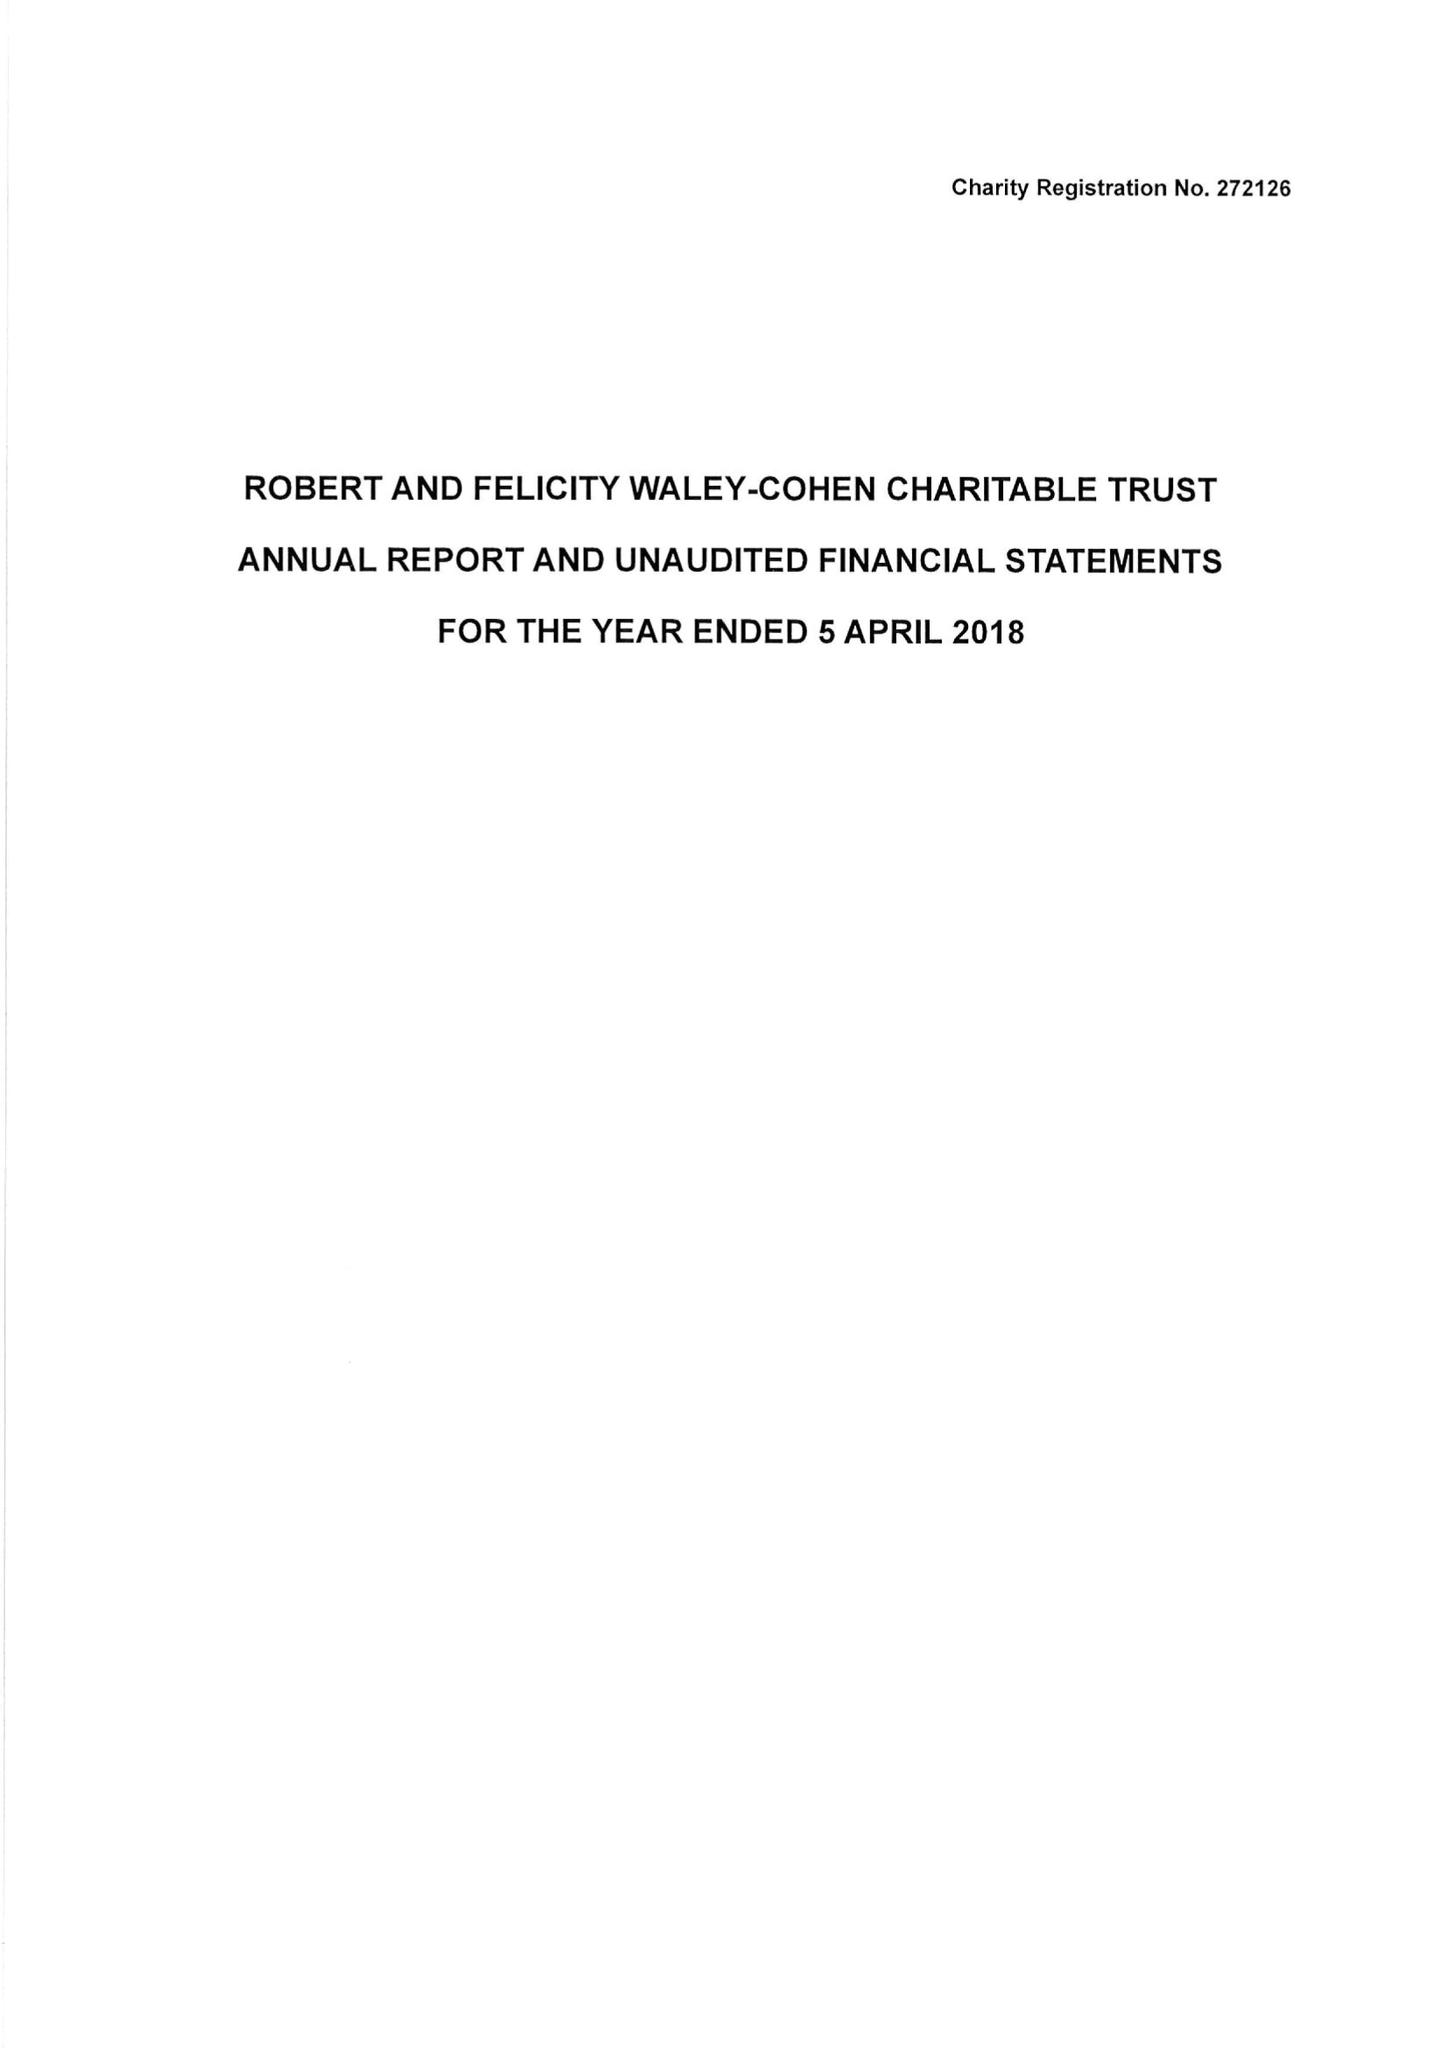What is the value for the address__street_line?
Answer the question using a single word or phrase. 27 SOUTH TERRACE 